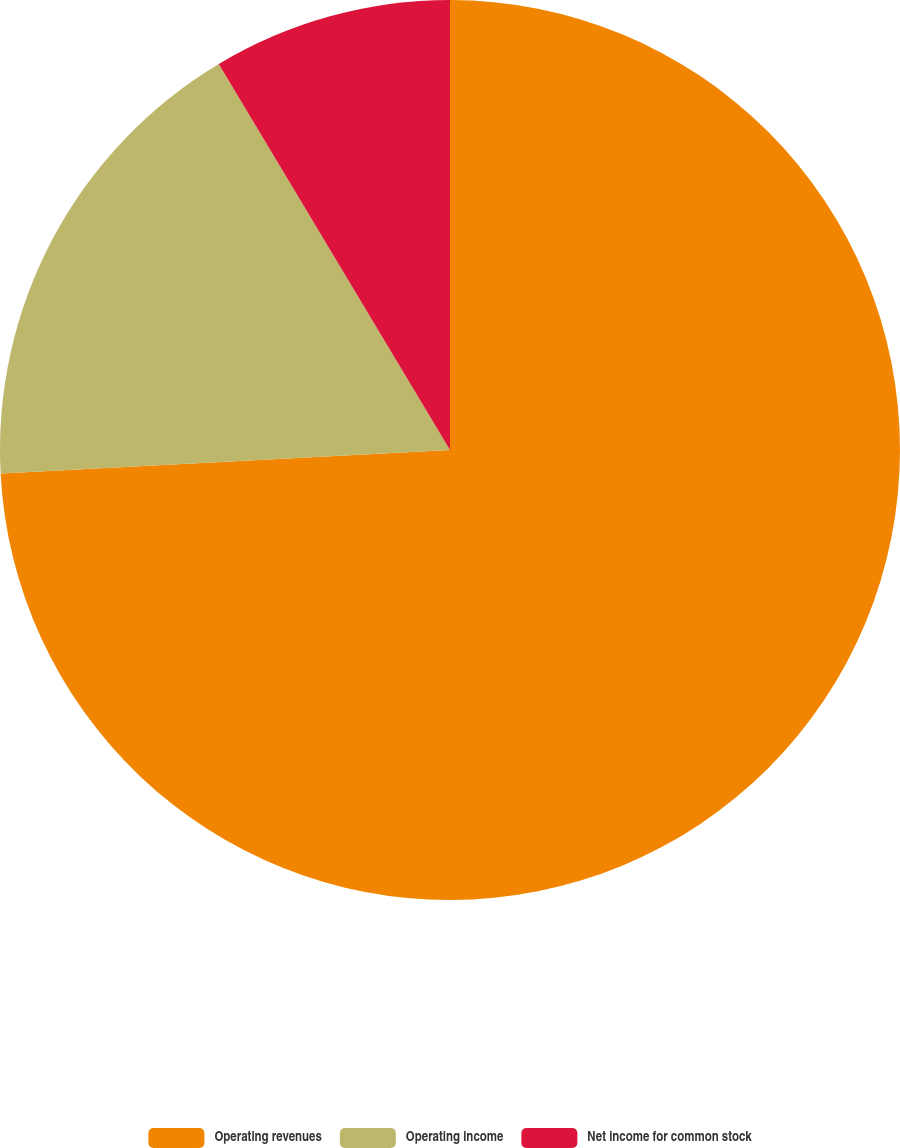Convert chart to OTSL. <chart><loc_0><loc_0><loc_500><loc_500><pie_chart><fcel>Operating revenues<fcel>Operating income<fcel>Net income for common stock<nl><fcel>74.17%<fcel>17.24%<fcel>8.59%<nl></chart> 